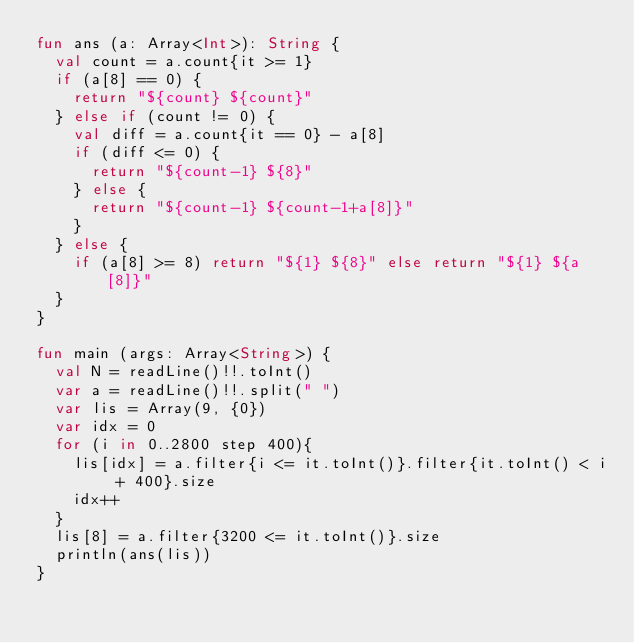<code> <loc_0><loc_0><loc_500><loc_500><_Kotlin_>fun ans (a: Array<Int>): String {
  val count = a.count{it >= 1}
  if (a[8] == 0) {
    return "${count} ${count}"
  } else if (count != 0) {
    val diff = a.count{it == 0} - a[8]
    if (diff <= 0) {
      return "${count-1} ${8}"
    } else {
      return "${count-1} ${count-1+a[8]}"
    }
  } else {
    if (a[8] >= 8) return "${1} ${8}" else return "${1} ${a[8]}"
  }
}

fun main (args: Array<String>) {
  val N = readLine()!!.toInt()
  var a = readLine()!!.split(" ")
  var lis = Array(9, {0})
  var idx = 0
  for (i in 0..2800 step 400){
    lis[idx] = a.filter{i <= it.toInt()}.filter{it.toInt() < i + 400}.size
    idx++
  }
  lis[8] = a.filter{3200 <= it.toInt()}.size
  println(ans(lis))
}
</code> 